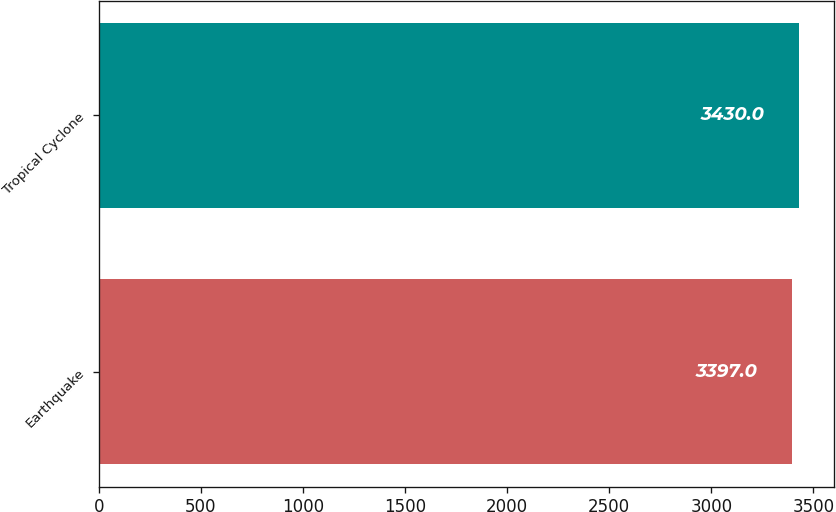Convert chart. <chart><loc_0><loc_0><loc_500><loc_500><bar_chart><fcel>Earthquake<fcel>Tropical Cyclone<nl><fcel>3397<fcel>3430<nl></chart> 